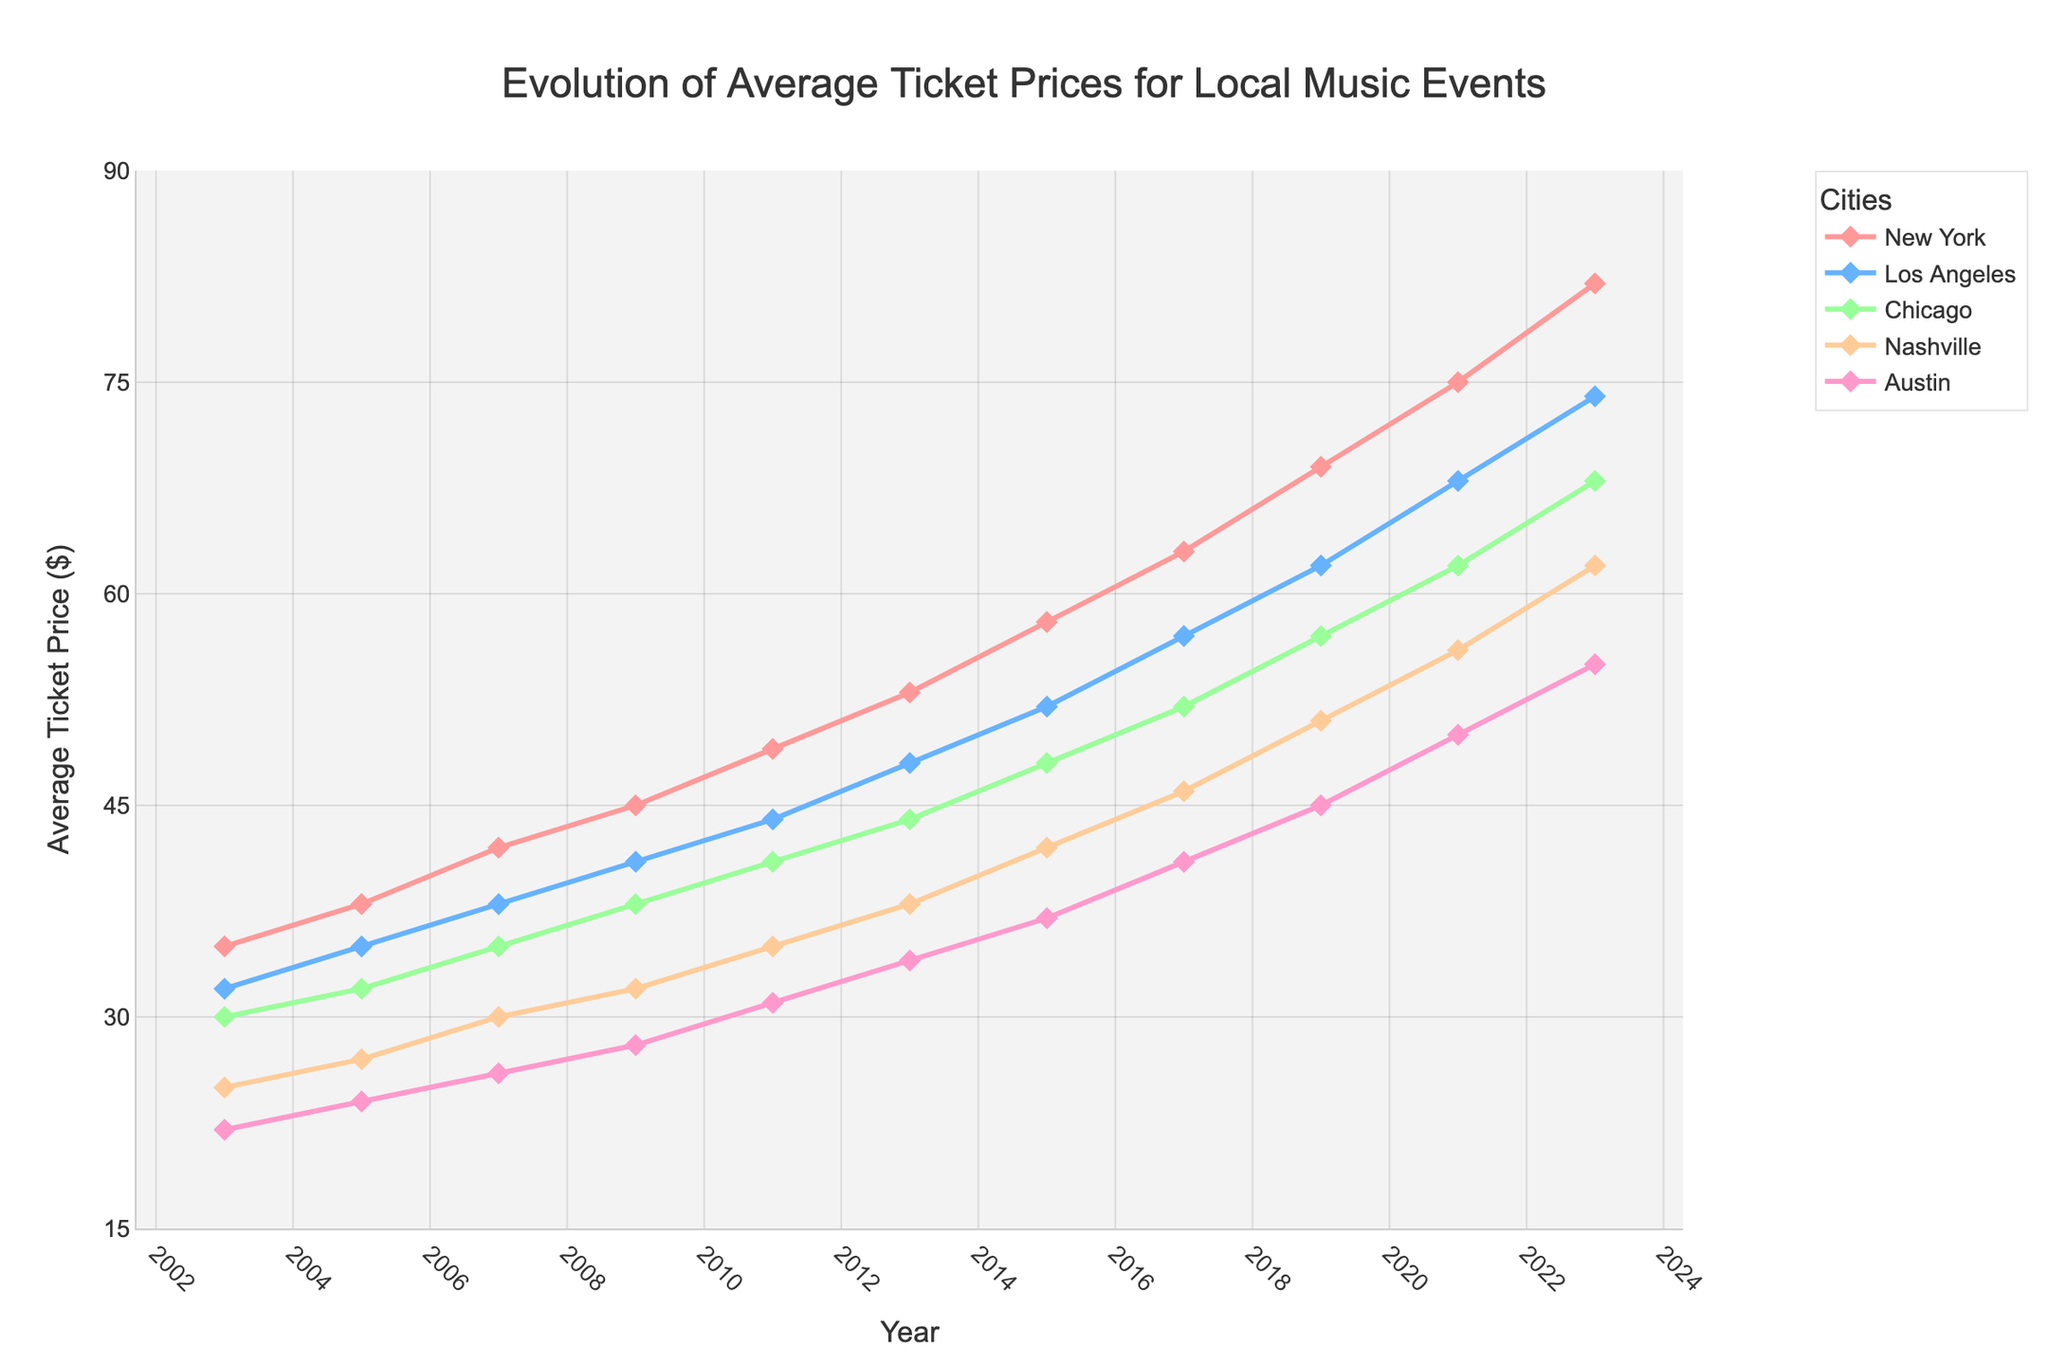What is the average ticket price in New York for the years presented in the chart? To find the average, sum all the ticket prices in New York for each year, then divide by the number of years: (35 + 38 + 42 + 45 + 49 + 53 + 58 + 63 + 69 + 75 + 82) / 11.
Answer: 53.36 Which city's average ticket price increased the most from 2003 to 2023? Calculate the difference between the 2023 price and the 2003 price for each city and compare: New York (82-35=47), Los Angeles (74-32=42), Chicago (68-30=38), Nashville (62-25=37), Austin (55-22=33). New York had the highest increase of 47 dollars.
Answer: New York How much more expensive were the average ticket prices in Los Angeles in 2023 compared to Chicago in 2023? Subtract the average ticket price in Chicago from that in Los Angeles for the year 2023: 74 - 68.
Answer: 6 Which city had the most consistent increase in average ticket price over the last 20 years? Look for the city with the smoothest and most linear increase in ticket prices from 2003 to 2023. Austin appears to have a consistent, linear increase compared to the other cities.
Answer: Austin By how much did the average ticket price increase in Nashville from 2003 to 2023? Subtract the 2003 price from the 2023 price for Nashville: 62 - 25.
Answer: 37 What is the difference in average ticket prices between New York and Austin in 2017? Subtract Austin's ticket price from New York's ticket price for the year 2017: 63 - 41.
Answer: 22 Which city had the highest average ticket price in 2015? Compare the 2015 ticket prices across all cities: New York (58), Los Angeles (52), Chicago (48), Nashville (42), Austin (37). New York had the highest price at 58 dollars.
Answer: New York What was the average ticket price in Austin in 2011? Just refer to the chart and locate the value for Austin in the year 2011, which is 31 dollars.
Answer: 31 From 2009 to 2013, which city saw the largest increase in ticket prices? Calculate the increase for each city between 2009 and 2013: New York (53-45=8), Los Angeles (48-41=7), Chicago (44-38=6), Nashville (38-32=6), Austin (34-28=6). New York saw the largest increase at 8 dollars.
Answer: New York How many cities had ticket prices above 60 dollars in 2021? Check the values on the chart for 2021: New York (75), Los Angeles (68), Chicago (62), Nashville (56), Austin (50). Only three cities (New York, Los Angeles, and Chicago) had prices above 60 dollars.
Answer: 3 